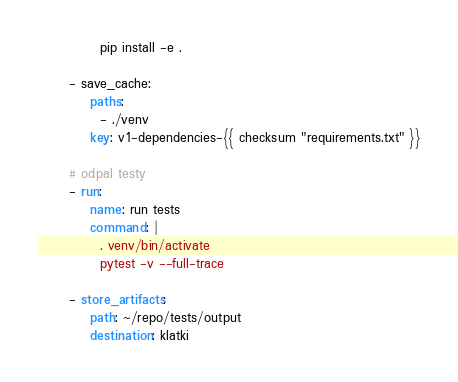Convert code to text. <code><loc_0><loc_0><loc_500><loc_500><_YAML_>            pip install -e .

      - save_cache:
          paths:
            - ./venv
          key: v1-dependencies-{{ checksum "requirements.txt" }}

      # odpal testy
      - run:
          name: run tests
          command: |
            . venv/bin/activate
            pytest -v --full-trace

      - store_artifacts:
          path: ~/repo/tests/output
          destination: klatki
</code> 